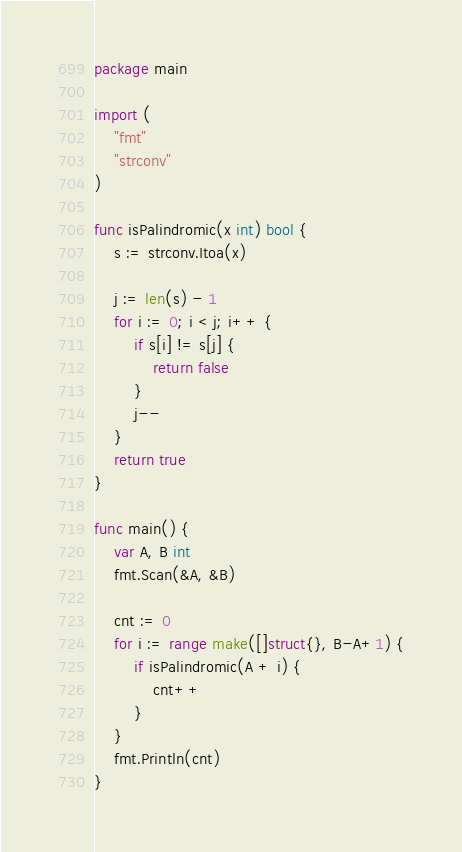Convert code to text. <code><loc_0><loc_0><loc_500><loc_500><_Go_>package main

import (
	"fmt"
	"strconv"
)

func isPalindromic(x int) bool {
	s := strconv.Itoa(x)

	j := len(s) - 1
	for i := 0; i < j; i++ {
		if s[i] != s[j] {
			return false
		}
		j--
	}
	return true
}

func main() {
	var A, B int
	fmt.Scan(&A, &B)

	cnt := 0
	for i := range make([]struct{}, B-A+1) {
		if isPalindromic(A + i) {
			cnt++
		}
	}
	fmt.Println(cnt)
}
</code> 